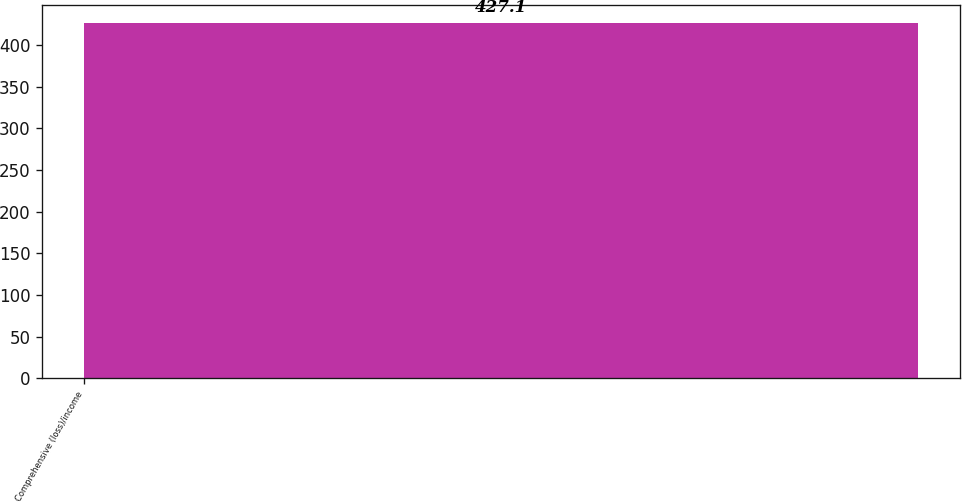<chart> <loc_0><loc_0><loc_500><loc_500><bar_chart><fcel>Comprehensive (loss)/income<nl><fcel>427.1<nl></chart> 